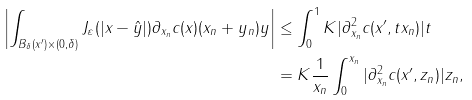<formula> <loc_0><loc_0><loc_500><loc_500>\left | \int _ { B _ { \delta } ( x ^ { \prime } ) \times ( 0 , \delta ) } J _ { \varepsilon } ( | x - \hat { y } | ) \partial _ { x _ { n } } c ( x ) ( x _ { n } + y _ { n } ) y \right | & \leq \int _ { 0 } ^ { 1 } K | \partial _ { x _ { n } } ^ { 2 } c ( x ^ { \prime } , t x _ { n } ) | t \\ & = K \frac { 1 } { x _ { n } } \int _ { 0 } ^ { x _ { n } } | \partial _ { x _ { n } } ^ { 2 } c ( x ^ { \prime } , z _ { n } ) | z _ { n } ,</formula> 